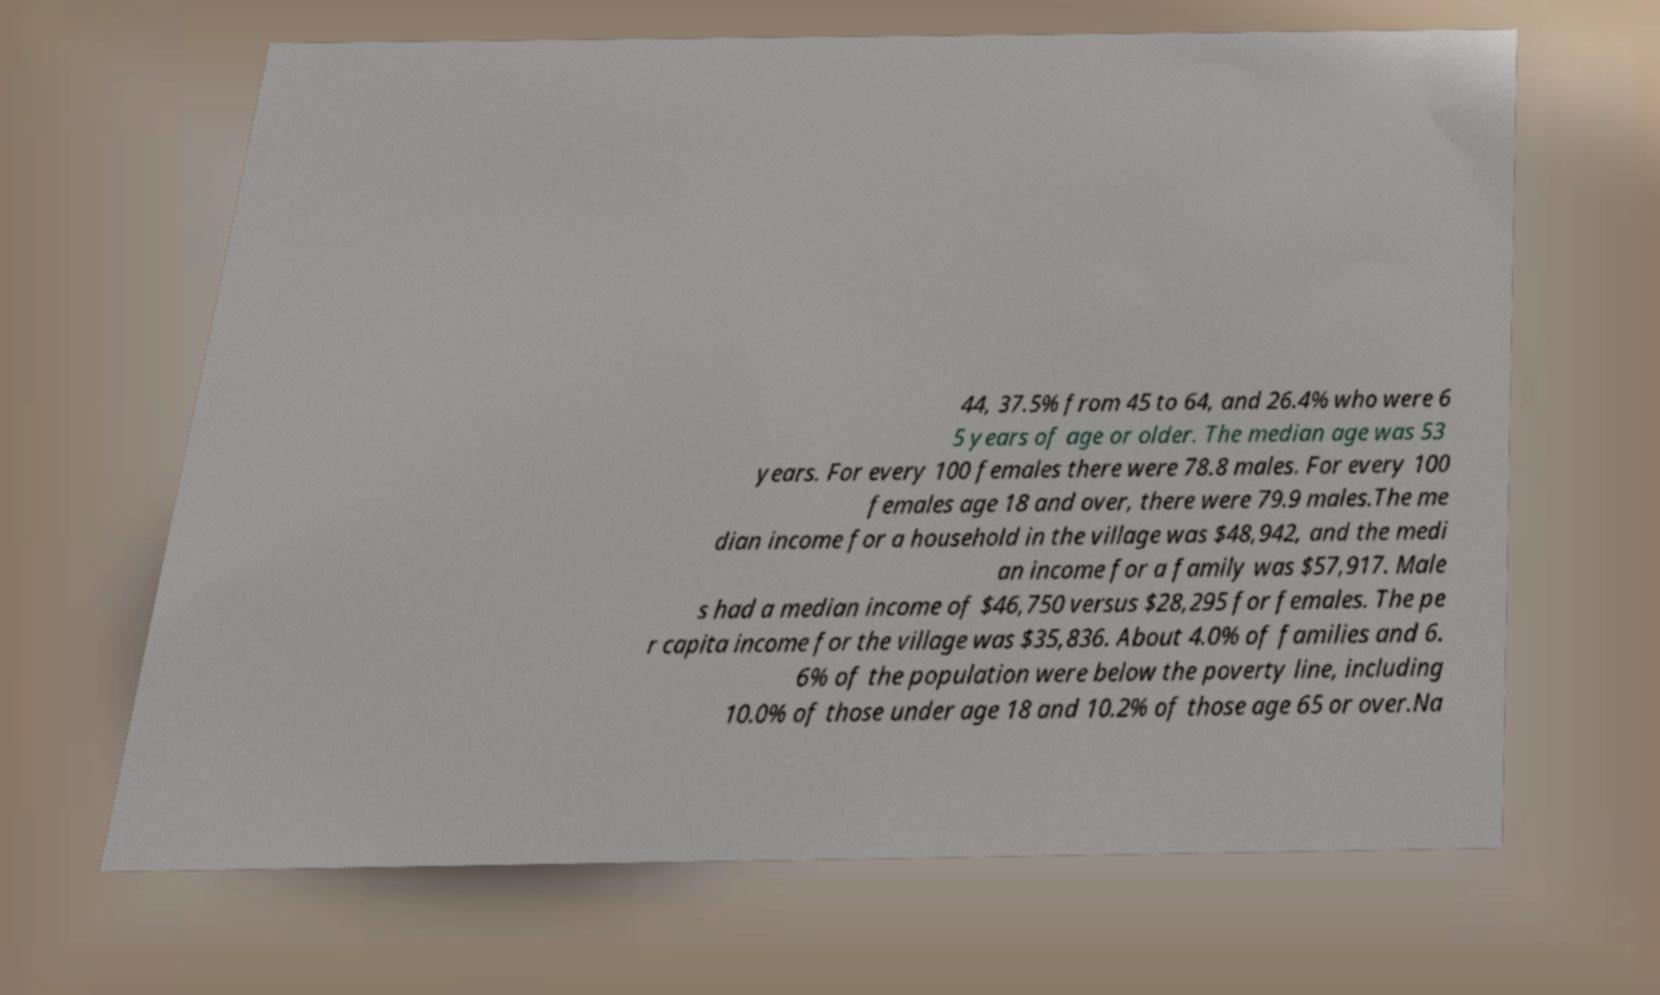What messages or text are displayed in this image? I need them in a readable, typed format. 44, 37.5% from 45 to 64, and 26.4% who were 6 5 years of age or older. The median age was 53 years. For every 100 females there were 78.8 males. For every 100 females age 18 and over, there were 79.9 males.The me dian income for a household in the village was $48,942, and the medi an income for a family was $57,917. Male s had a median income of $46,750 versus $28,295 for females. The pe r capita income for the village was $35,836. About 4.0% of families and 6. 6% of the population were below the poverty line, including 10.0% of those under age 18 and 10.2% of those age 65 or over.Na 